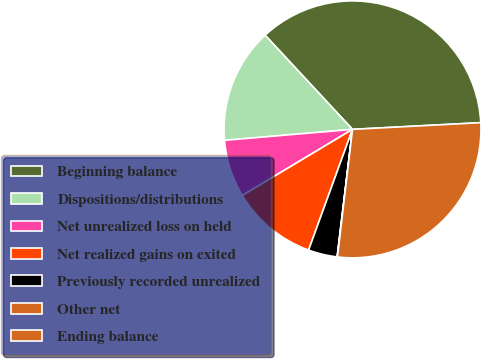Convert chart. <chart><loc_0><loc_0><loc_500><loc_500><pie_chart><fcel>Beginning balance<fcel>Dispositions/distributions<fcel>Net unrealized loss on held<fcel>Net realized gains on exited<fcel>Previously recorded unrealized<fcel>Other net<fcel>Ending balance<nl><fcel>36.08%<fcel>14.45%<fcel>7.24%<fcel>10.85%<fcel>3.64%<fcel>0.04%<fcel>27.7%<nl></chart> 